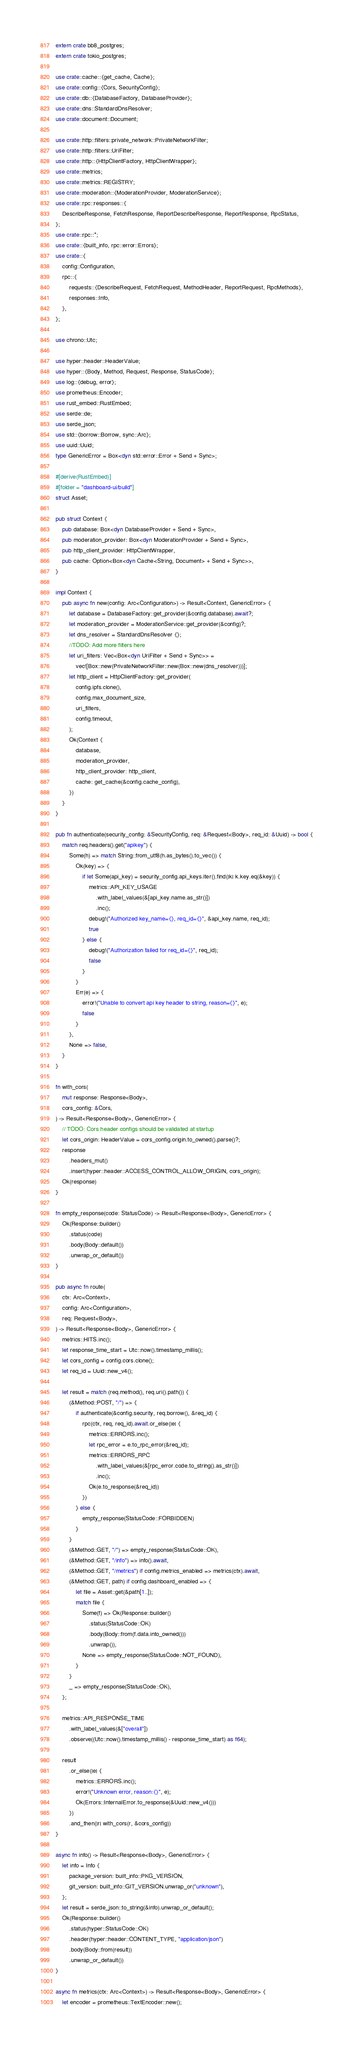<code> <loc_0><loc_0><loc_500><loc_500><_Rust_>extern crate bb8_postgres;
extern crate tokio_postgres;

use crate::cache::{get_cache, Cache};
use crate::config::{Cors, SecurityConfig};
use crate::db::{DatabaseFactory, DatabaseProvider};
use crate::dns::StandardDnsResolver;
use crate::document::Document;

use crate::http::filters::private_network::PrivateNetworkFilter;
use crate::http::filters::UriFilter;
use crate::http::{HttpClientFactory, HttpClientWrapper};
use crate::metrics;
use crate::metrics::REGISTRY;
use crate::moderation::{ModerationProvider, ModerationService};
use crate::rpc::responses::{
    DescribeResponse, FetchResponse, ReportDescribeResponse, ReportResponse, RpcStatus,
};
use crate::rpc::*;
use crate::{built_info, rpc::error::Errors};
use crate::{
    config::Configuration,
    rpc::{
        requests::{DescribeRequest, FetchRequest, MethodHeader, ReportRequest, RpcMethods},
        responses::Info,
    },
};

use chrono::Utc;

use hyper::header::HeaderValue;
use hyper::{Body, Method, Request, Response, StatusCode};
use log::{debug, error};
use prometheus::Encoder;
use rust_embed::RustEmbed;
use serde::de;
use serde_json;
use std::{borrow::Borrow, sync::Arc};
use uuid::Uuid;
type GenericError = Box<dyn std::error::Error + Send + Sync>;

#[derive(RustEmbed)]
#[folder = "dashboard-ui/build"]
struct Asset;

pub struct Context {
    pub database: Box<dyn DatabaseProvider + Send + Sync>,
    pub moderation_provider: Box<dyn ModerationProvider + Send + Sync>,
    pub http_client_provider: HttpClientWrapper,
    pub cache: Option<Box<dyn Cache<String, Document> + Send + Sync>>,
}

impl Context {
    pub async fn new(config: Arc<Configuration>) -> Result<Context, GenericError> {
        let database = DatabaseFactory::get_provider(&config.database).await?;
        let moderation_provider = ModerationService::get_provider(&config)?;
        let dns_resolver = StandardDnsResolver {};
        //TODO: Add more filters here
        let uri_filters: Vec<Box<dyn UriFilter + Send + Sync>> =
            vec![Box::new(PrivateNetworkFilter::new(Box::new(dns_resolver)))];
        let http_client = HttpClientFactory::get_provider(
            config.ipfs.clone(),
            config.max_document_size,
            uri_filters,
            config.timeout,
        );
        Ok(Context {
            database,
            moderation_provider,
            http_client_provider: http_client,
            cache: get_cache(&config.cache_config),
        })
    }
}

pub fn authenticate(security_config: &SecurityConfig, req: &Request<Body>, req_id: &Uuid) -> bool {
    match req.headers().get("apikey") {
        Some(h) => match String::from_utf8(h.as_bytes().to_vec()) {
            Ok(key) => {
                if let Some(api_key) = security_config.api_keys.iter().find(|k| k.key.eq(&key)) {
                    metrics::API_KEY_USAGE
                        .with_label_values(&[api_key.name.as_str()])
                        .inc();
                    debug!("Authorized key_name={}, req_id={}", &api_key.name, req_id);
                    true
                } else {
                    debug!("Authorization failed for req_id={}", req_id);
                    false
                }
            }
            Err(e) => {
                error!("Unable to convert api key header to string, reason={}", e);
                false
            }
        },
        None => false,
    }
}

fn with_cors(
    mut response: Response<Body>,
    cors_config: &Cors,
) -> Result<Response<Body>, GenericError> {
    // TODO: Cors header configs should be validated at startup
    let cors_origin: HeaderValue = cors_config.origin.to_owned().parse()?;
    response
        .headers_mut()
        .insert(hyper::header::ACCESS_CONTROL_ALLOW_ORIGIN, cors_origin);
    Ok(response)
}

fn empty_response(code: StatusCode) -> Result<Response<Body>, GenericError> {
    Ok(Response::builder()
        .status(code)
        .body(Body::default())
        .unwrap_or_default())
}

pub async fn route(
    ctx: Arc<Context>,
    config: Arc<Configuration>,
    req: Request<Body>,
) -> Result<Response<Body>, GenericError> {
    metrics::HITS.inc();
    let response_time_start = Utc::now().timestamp_millis();
    let cors_config = config.cors.clone();
    let req_id = Uuid::new_v4();

    let result = match (req.method(), req.uri().path()) {
        (&Method::POST, "/") => {
            if authenticate(&config.security, req.borrow(), &req_id) {
                rpc(ctx, req, req_id).await.or_else(|e| {
                    metrics::ERRORS.inc();
                    let rpc_error = e.to_rpc_error(&req_id);
                    metrics::ERRORS_RPC
                        .with_label_values(&[rpc_error.code.to_string().as_str()])
                        .inc();
                    Ok(e.to_response(&req_id))
                })
            } else {
                empty_response(StatusCode::FORBIDDEN)
            }
        }
        (&Method::GET, "/") => empty_response(StatusCode::OK),
        (&Method::GET, "/info") => info().await,
        (&Method::GET, "/metrics") if config.metrics_enabled => metrics(ctx).await,
        (&Method::GET, path) if config.dashboard_enabled => {
            let file = Asset::get(&path[1..]);
            match file {
                Some(f) => Ok(Response::builder()
                    .status(StatusCode::OK)
                    .body(Body::from(f.data.into_owned()))
                    .unwrap()),
                None => empty_response(StatusCode::NOT_FOUND),
            }
        }
        _ => empty_response(StatusCode::OK),
    };

    metrics::API_RESPONSE_TIME
        .with_label_values(&["overall"])
        .observe((Utc::now().timestamp_millis() - response_time_start) as f64);

    result
        .or_else(|e| {
            metrics::ERRORS.inc();
            error!("Unknown error, reason:{}", e);
            Ok(Errors::InternalError.to_response(&Uuid::new_v4()))
        })
        .and_then(|r| with_cors(r, &cors_config))
}

async fn info() -> Result<Response<Body>, GenericError> {
    let info = Info {
        package_version: built_info::PKG_VERSION,
        git_version: built_info::GIT_VERSION.unwrap_or("unknown"),
    };
    let result = serde_json::to_string(&info).unwrap_or_default();
    Ok(Response::builder()
        .status(hyper::StatusCode::OK)
        .header(hyper::header::CONTENT_TYPE, "application/json")
        .body(Body::from(result))
        .unwrap_or_default())
}

async fn metrics(ctx: Arc<Context>) -> Result<Response<Body>, GenericError> {
    let encoder = prometheus::TextEncoder::new();</code> 